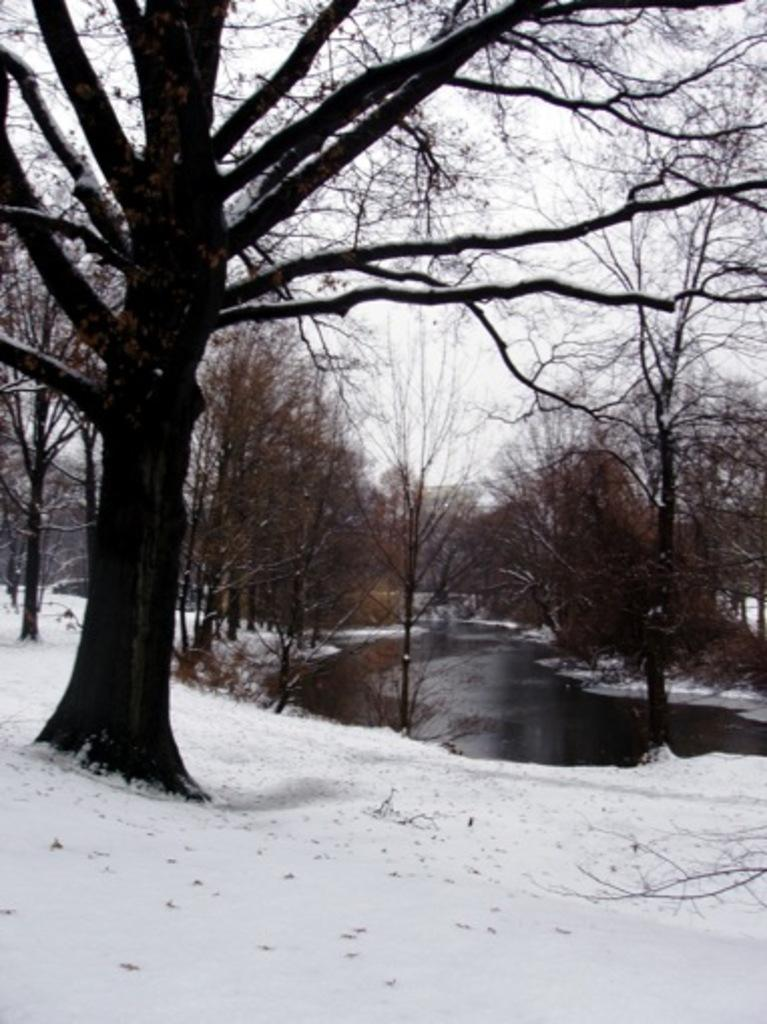What is located in the foreground of the image? There is a tree in the foreground of the image. What is visible in the background of the image? There is a river and snow in the background of the image. What else can be seen in the background of the image? The sky is visible in the background of the image. How many sticks are being used by the spy in the image? There is no spy or sticks present in the image. What type of comb is being used by the person in the image? There is no person or comb present in the image. 